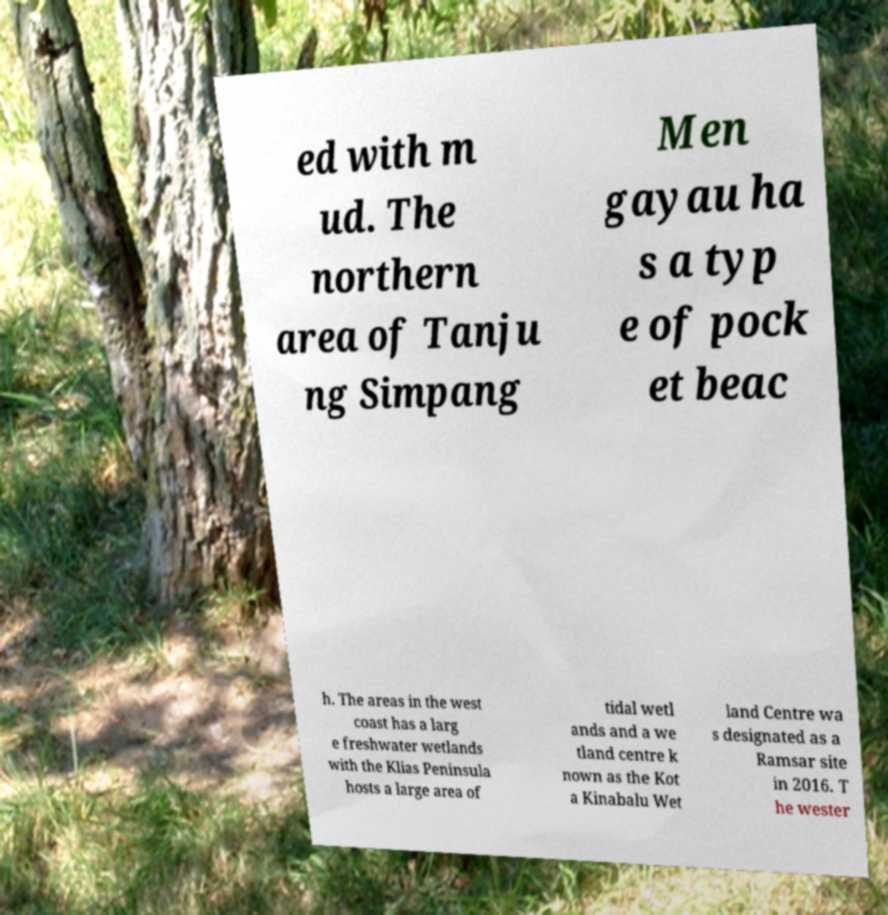Could you assist in decoding the text presented in this image and type it out clearly? ed with m ud. The northern area of Tanju ng Simpang Men gayau ha s a typ e of pock et beac h. The areas in the west coast has a larg e freshwater wetlands with the Klias Peninsula hosts a large area of tidal wetl ands and a we tland centre k nown as the Kot a Kinabalu Wet land Centre wa s designated as a Ramsar site in 2016. T he wester 